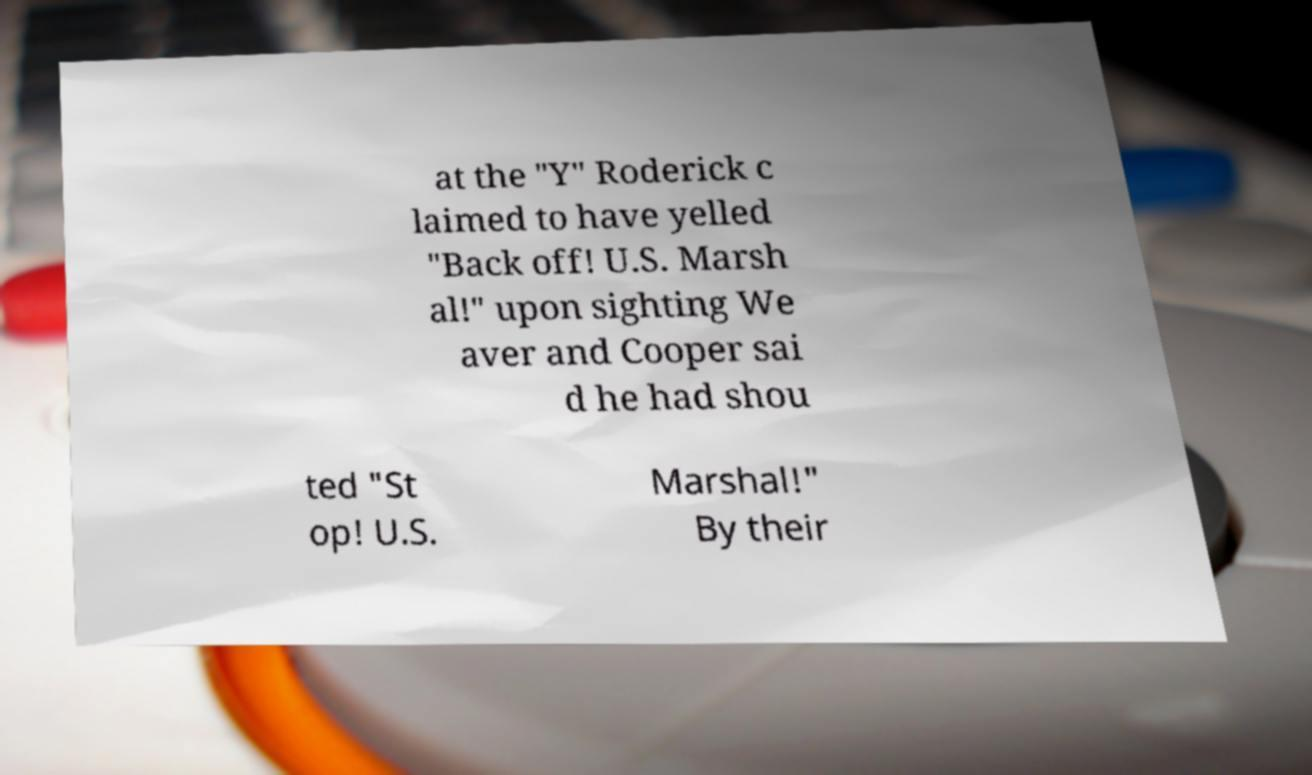What messages or text are displayed in this image? I need them in a readable, typed format. at the "Y" Roderick c laimed to have yelled "Back off! U.S. Marsh al!" upon sighting We aver and Cooper sai d he had shou ted "St op! U.S. Marshal!" By their 